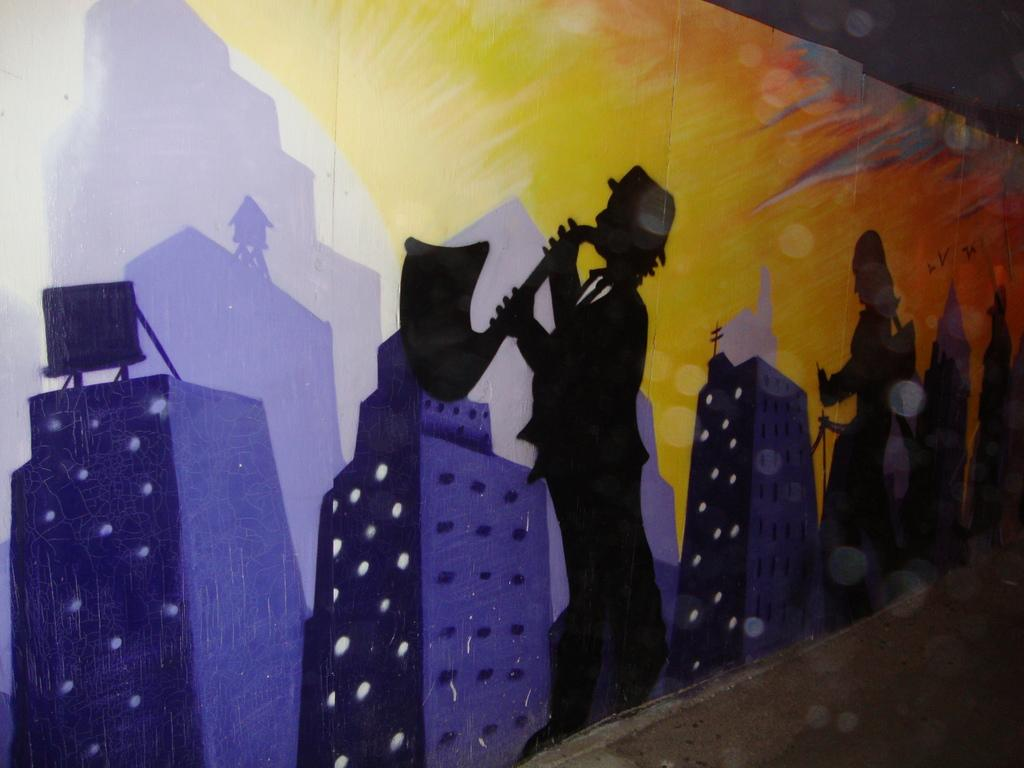What can be seen on the walls in the image? There are wall paintings in the image. Can you describe the setting in which the wall paintings are located? The image may have been taken in a hall. What is the texture of the disgust in the image? There is no disgust present in the image, so it is not possible to determine its texture. 